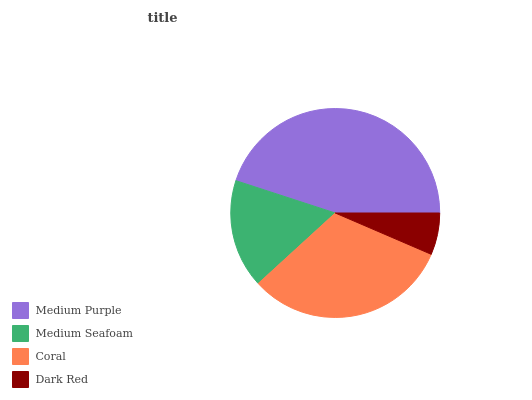Is Dark Red the minimum?
Answer yes or no. Yes. Is Medium Purple the maximum?
Answer yes or no. Yes. Is Medium Seafoam the minimum?
Answer yes or no. No. Is Medium Seafoam the maximum?
Answer yes or no. No. Is Medium Purple greater than Medium Seafoam?
Answer yes or no. Yes. Is Medium Seafoam less than Medium Purple?
Answer yes or no. Yes. Is Medium Seafoam greater than Medium Purple?
Answer yes or no. No. Is Medium Purple less than Medium Seafoam?
Answer yes or no. No. Is Coral the high median?
Answer yes or no. Yes. Is Medium Seafoam the low median?
Answer yes or no. Yes. Is Dark Red the high median?
Answer yes or no. No. Is Medium Purple the low median?
Answer yes or no. No. 